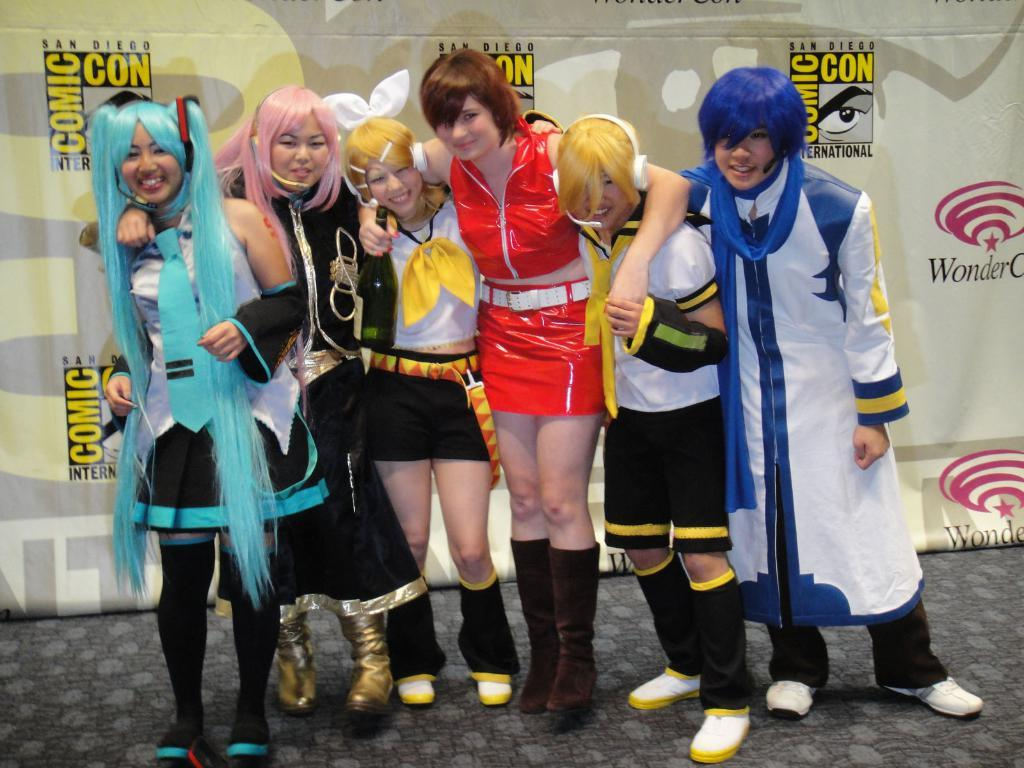<image>
Give a short and clear explanation of the subsequent image. a comic con ad behind some kids that are posing 